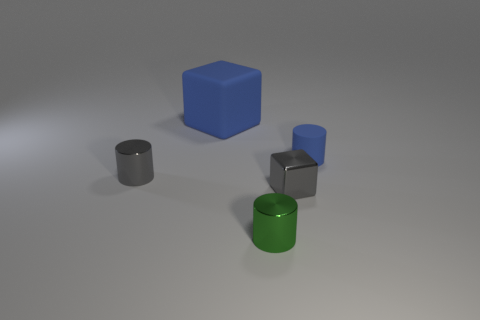Add 3 tiny brown matte spheres. How many objects exist? 8 Subtract all cubes. How many objects are left? 3 Subtract all green objects. Subtract all cylinders. How many objects are left? 1 Add 2 metallic cylinders. How many metallic cylinders are left? 4 Add 4 tiny yellow metal cylinders. How many tiny yellow metal cylinders exist? 4 Subtract 0 blue spheres. How many objects are left? 5 